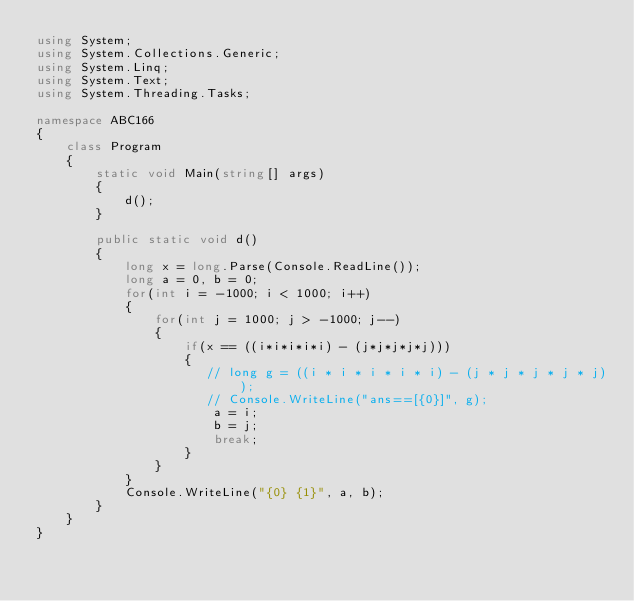<code> <loc_0><loc_0><loc_500><loc_500><_C#_>using System;
using System.Collections.Generic;
using System.Linq;
using System.Text;
using System.Threading.Tasks;

namespace ABC166
{
    class Program
    {
        static void Main(string[] args)
        {
            d();
        }

        public static void d()
        {
            long x = long.Parse(Console.ReadLine());
            long a = 0, b = 0;
            for(int i = -1000; i < 1000; i++)
            {
                for(int j = 1000; j > -1000; j--)
                {
                    if(x == ((i*i*i*i*i) - (j*j*j*j*j)))
                    {
                       // long g = ((i * i * i * i * i) - (j * j * j * j * j));
                       // Console.WriteLine("ans==[{0}]", g);
                        a = i;
                        b = j;
                        break;
                    }
                }
            }
            Console.WriteLine("{0} {1}", a, b);
        }
    }
}
</code> 